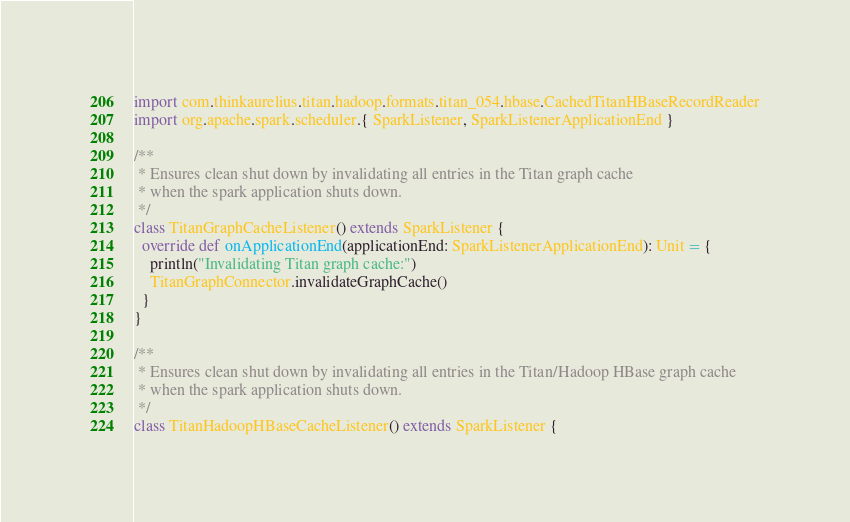Convert code to text. <code><loc_0><loc_0><loc_500><loc_500><_Scala_>
import com.thinkaurelius.titan.hadoop.formats.titan_054.hbase.CachedTitanHBaseRecordReader
import org.apache.spark.scheduler.{ SparkListener, SparkListenerApplicationEnd }

/**
 * Ensures clean shut down by invalidating all entries in the Titan graph cache
 * when the spark application shuts down.
 */
class TitanGraphCacheListener() extends SparkListener {
  override def onApplicationEnd(applicationEnd: SparkListenerApplicationEnd): Unit = {
    println("Invalidating Titan graph cache:")
    TitanGraphConnector.invalidateGraphCache()
  }
}

/**
 * Ensures clean shut down by invalidating all entries in the Titan/Hadoop HBase graph cache
 * when the spark application shuts down.
 */
class TitanHadoopHBaseCacheListener() extends SparkListener {
</code> 